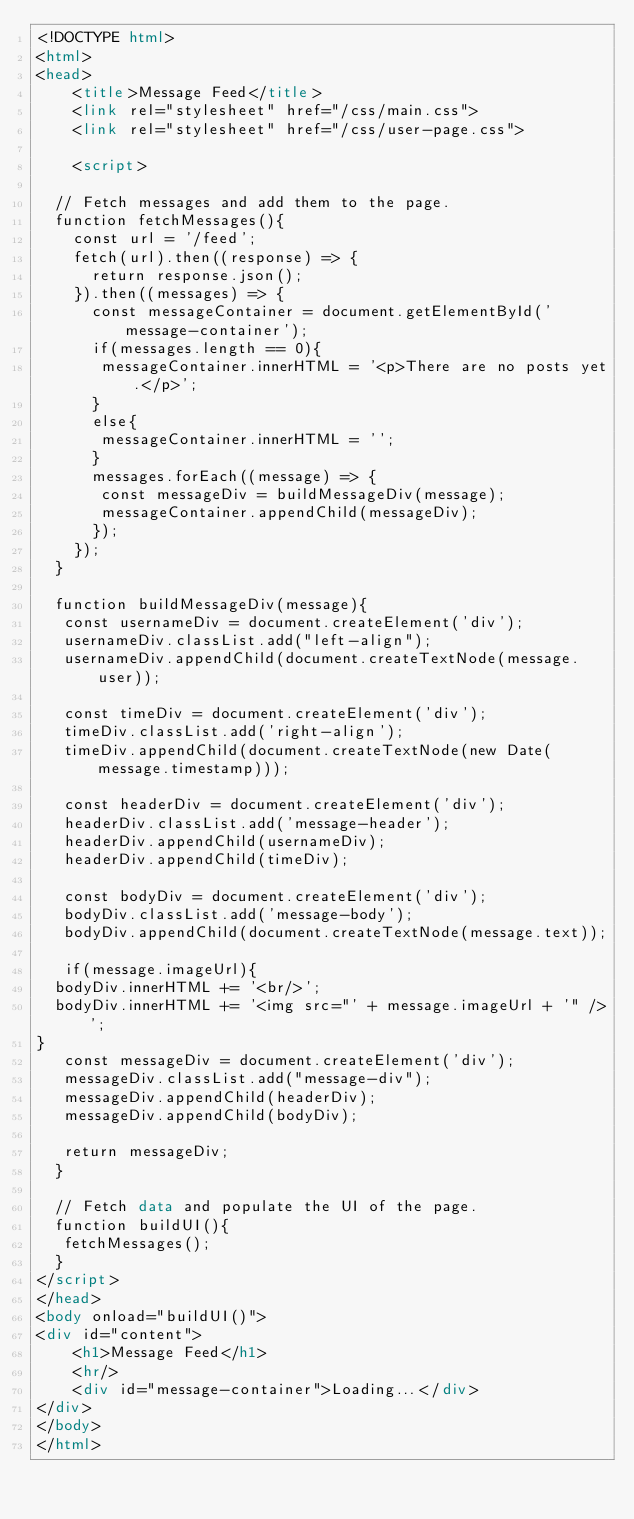Convert code to text. <code><loc_0><loc_0><loc_500><loc_500><_HTML_><!DOCTYPE html>
<html>
<head>
    <title>Message Feed</title>
    <link rel="stylesheet" href="/css/main.css">
    <link rel="stylesheet" href="/css/user-page.css">

    <script>

  // Fetch messages and add them to the page.
  function fetchMessages(){
    const url = '/feed';
    fetch(url).then((response) => {
      return response.json();
    }).then((messages) => {
      const messageContainer = document.getElementById('message-container');
      if(messages.length == 0){
       messageContainer.innerHTML = '<p>There are no posts yet.</p>';
      }
      else{
       messageContainer.innerHTML = '';
      }
      messages.forEach((message) => {
       const messageDiv = buildMessageDiv(message);
       messageContainer.appendChild(messageDiv);
      });
    });
  }

  function buildMessageDiv(message){
   const usernameDiv = document.createElement('div');
   usernameDiv.classList.add("left-align");
   usernameDiv.appendChild(document.createTextNode(message.user));

   const timeDiv = document.createElement('div');
   timeDiv.classList.add('right-align');
   timeDiv.appendChild(document.createTextNode(new Date(message.timestamp)));

   const headerDiv = document.createElement('div');
   headerDiv.classList.add('message-header');
   headerDiv.appendChild(usernameDiv);
   headerDiv.appendChild(timeDiv);

   const bodyDiv = document.createElement('div');
   bodyDiv.classList.add('message-body');
   bodyDiv.appendChild(document.createTextNode(message.text));

   if(message.imageUrl){
  bodyDiv.innerHTML += '<br/>';
  bodyDiv.innerHTML += '<img src="' + message.imageUrl + '" />';
}
   const messageDiv = document.createElement('div');
   messageDiv.classList.add("message-div");
   messageDiv.appendChild(headerDiv);
   messageDiv.appendChild(bodyDiv);

   return messageDiv;
  }

  // Fetch data and populate the UI of the page.
  function buildUI(){
   fetchMessages();
  }
</script>
</head>
<body onload="buildUI()">
<div id="content">
    <h1>Message Feed</h1>
    <hr/>
    <div id="message-container">Loading...</div>
</div>
</body>
</html></code> 